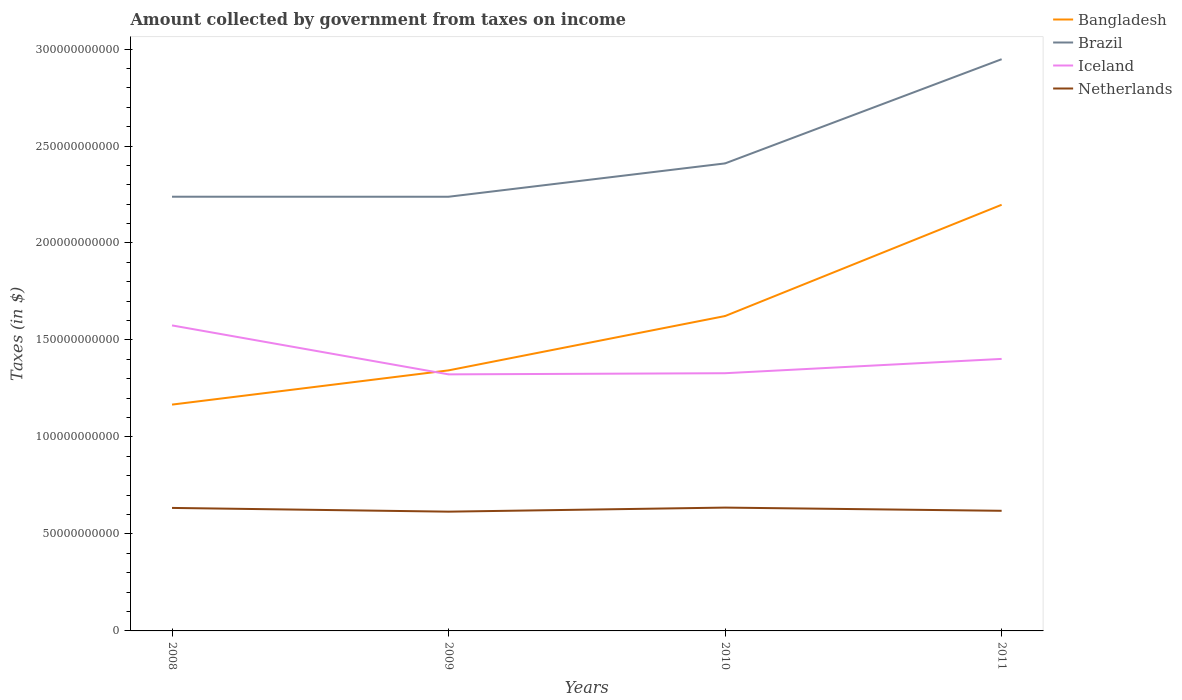Does the line corresponding to Netherlands intersect with the line corresponding to Bangladesh?
Offer a terse response. No. Is the number of lines equal to the number of legend labels?
Offer a very short reply. Yes. Across all years, what is the maximum amount collected by government from taxes on income in Netherlands?
Provide a short and direct response. 6.15e+1. What is the total amount collected by government from taxes on income in Brazil in the graph?
Your answer should be very brief. -7.09e+1. What is the difference between the highest and the second highest amount collected by government from taxes on income in Bangladesh?
Your answer should be compact. 1.03e+11. How many lines are there?
Ensure brevity in your answer.  4. Are the values on the major ticks of Y-axis written in scientific E-notation?
Provide a succinct answer. No. Does the graph contain any zero values?
Keep it short and to the point. No. Does the graph contain grids?
Make the answer very short. No. How many legend labels are there?
Ensure brevity in your answer.  4. What is the title of the graph?
Give a very brief answer. Amount collected by government from taxes on income. Does "Comoros" appear as one of the legend labels in the graph?
Provide a succinct answer. No. What is the label or title of the X-axis?
Keep it short and to the point. Years. What is the label or title of the Y-axis?
Give a very brief answer. Taxes (in $). What is the Taxes (in $) of Bangladesh in 2008?
Give a very brief answer. 1.17e+11. What is the Taxes (in $) of Brazil in 2008?
Ensure brevity in your answer.  2.24e+11. What is the Taxes (in $) in Iceland in 2008?
Provide a succinct answer. 1.58e+11. What is the Taxes (in $) of Netherlands in 2008?
Your answer should be very brief. 6.34e+1. What is the Taxes (in $) in Bangladesh in 2009?
Your response must be concise. 1.34e+11. What is the Taxes (in $) in Brazil in 2009?
Your answer should be compact. 2.24e+11. What is the Taxes (in $) of Iceland in 2009?
Offer a terse response. 1.32e+11. What is the Taxes (in $) in Netherlands in 2009?
Provide a succinct answer. 6.15e+1. What is the Taxes (in $) in Bangladesh in 2010?
Keep it short and to the point. 1.62e+11. What is the Taxes (in $) in Brazil in 2010?
Ensure brevity in your answer.  2.41e+11. What is the Taxes (in $) in Iceland in 2010?
Your answer should be very brief. 1.33e+11. What is the Taxes (in $) of Netherlands in 2010?
Offer a terse response. 6.36e+1. What is the Taxes (in $) of Bangladesh in 2011?
Provide a short and direct response. 2.20e+11. What is the Taxes (in $) in Brazil in 2011?
Your response must be concise. 2.95e+11. What is the Taxes (in $) of Iceland in 2011?
Provide a short and direct response. 1.40e+11. What is the Taxes (in $) of Netherlands in 2011?
Make the answer very short. 6.19e+1. Across all years, what is the maximum Taxes (in $) of Bangladesh?
Offer a terse response. 2.20e+11. Across all years, what is the maximum Taxes (in $) of Brazil?
Your response must be concise. 2.95e+11. Across all years, what is the maximum Taxes (in $) of Iceland?
Ensure brevity in your answer.  1.58e+11. Across all years, what is the maximum Taxes (in $) of Netherlands?
Keep it short and to the point. 6.36e+1. Across all years, what is the minimum Taxes (in $) of Bangladesh?
Keep it short and to the point. 1.17e+11. Across all years, what is the minimum Taxes (in $) in Brazil?
Give a very brief answer. 2.24e+11. Across all years, what is the minimum Taxes (in $) of Iceland?
Your answer should be very brief. 1.32e+11. Across all years, what is the minimum Taxes (in $) of Netherlands?
Your answer should be compact. 6.15e+1. What is the total Taxes (in $) in Bangladesh in the graph?
Offer a terse response. 6.33e+11. What is the total Taxes (in $) in Brazil in the graph?
Your response must be concise. 9.84e+11. What is the total Taxes (in $) of Iceland in the graph?
Give a very brief answer. 5.63e+11. What is the total Taxes (in $) in Netherlands in the graph?
Your answer should be compact. 2.50e+11. What is the difference between the Taxes (in $) in Bangladesh in 2008 and that in 2009?
Provide a short and direct response. -1.76e+1. What is the difference between the Taxes (in $) of Brazil in 2008 and that in 2009?
Provide a short and direct response. 1.68e+07. What is the difference between the Taxes (in $) in Iceland in 2008 and that in 2009?
Your answer should be very brief. 2.52e+1. What is the difference between the Taxes (in $) in Netherlands in 2008 and that in 2009?
Your response must be concise. 1.93e+09. What is the difference between the Taxes (in $) in Bangladesh in 2008 and that in 2010?
Provide a short and direct response. -4.57e+1. What is the difference between the Taxes (in $) of Brazil in 2008 and that in 2010?
Your answer should be very brief. -1.72e+1. What is the difference between the Taxes (in $) of Iceland in 2008 and that in 2010?
Ensure brevity in your answer.  2.46e+1. What is the difference between the Taxes (in $) in Netherlands in 2008 and that in 2010?
Make the answer very short. -1.63e+08. What is the difference between the Taxes (in $) of Bangladesh in 2008 and that in 2011?
Give a very brief answer. -1.03e+11. What is the difference between the Taxes (in $) in Brazil in 2008 and that in 2011?
Provide a succinct answer. -7.09e+1. What is the difference between the Taxes (in $) of Iceland in 2008 and that in 2011?
Provide a short and direct response. 1.73e+1. What is the difference between the Taxes (in $) in Netherlands in 2008 and that in 2011?
Your answer should be compact. 1.49e+09. What is the difference between the Taxes (in $) of Bangladesh in 2009 and that in 2010?
Your answer should be compact. -2.80e+1. What is the difference between the Taxes (in $) in Brazil in 2009 and that in 2010?
Offer a terse response. -1.72e+1. What is the difference between the Taxes (in $) of Iceland in 2009 and that in 2010?
Ensure brevity in your answer.  -5.93e+08. What is the difference between the Taxes (in $) of Netherlands in 2009 and that in 2010?
Your response must be concise. -2.09e+09. What is the difference between the Taxes (in $) of Bangladesh in 2009 and that in 2011?
Your answer should be compact. -8.54e+1. What is the difference between the Taxes (in $) in Brazil in 2009 and that in 2011?
Your answer should be very brief. -7.09e+1. What is the difference between the Taxes (in $) in Iceland in 2009 and that in 2011?
Provide a succinct answer. -7.97e+09. What is the difference between the Taxes (in $) in Netherlands in 2009 and that in 2011?
Provide a succinct answer. -4.40e+08. What is the difference between the Taxes (in $) in Bangladesh in 2010 and that in 2011?
Your answer should be very brief. -5.74e+1. What is the difference between the Taxes (in $) of Brazil in 2010 and that in 2011?
Your response must be concise. -5.37e+1. What is the difference between the Taxes (in $) of Iceland in 2010 and that in 2011?
Offer a terse response. -7.37e+09. What is the difference between the Taxes (in $) in Netherlands in 2010 and that in 2011?
Provide a succinct answer. 1.65e+09. What is the difference between the Taxes (in $) of Bangladesh in 2008 and the Taxes (in $) of Brazil in 2009?
Make the answer very short. -1.07e+11. What is the difference between the Taxes (in $) of Bangladesh in 2008 and the Taxes (in $) of Iceland in 2009?
Keep it short and to the point. -1.56e+1. What is the difference between the Taxes (in $) of Bangladesh in 2008 and the Taxes (in $) of Netherlands in 2009?
Give a very brief answer. 5.52e+1. What is the difference between the Taxes (in $) in Brazil in 2008 and the Taxes (in $) in Iceland in 2009?
Keep it short and to the point. 9.16e+1. What is the difference between the Taxes (in $) in Brazil in 2008 and the Taxes (in $) in Netherlands in 2009?
Your response must be concise. 1.62e+11. What is the difference between the Taxes (in $) in Iceland in 2008 and the Taxes (in $) in Netherlands in 2009?
Offer a very short reply. 9.60e+1. What is the difference between the Taxes (in $) in Bangladesh in 2008 and the Taxes (in $) in Brazil in 2010?
Give a very brief answer. -1.24e+11. What is the difference between the Taxes (in $) in Bangladesh in 2008 and the Taxes (in $) in Iceland in 2010?
Provide a succinct answer. -1.62e+1. What is the difference between the Taxes (in $) in Bangladesh in 2008 and the Taxes (in $) in Netherlands in 2010?
Provide a short and direct response. 5.31e+1. What is the difference between the Taxes (in $) in Brazil in 2008 and the Taxes (in $) in Iceland in 2010?
Keep it short and to the point. 9.10e+1. What is the difference between the Taxes (in $) of Brazil in 2008 and the Taxes (in $) of Netherlands in 2010?
Provide a succinct answer. 1.60e+11. What is the difference between the Taxes (in $) in Iceland in 2008 and the Taxes (in $) in Netherlands in 2010?
Make the answer very short. 9.39e+1. What is the difference between the Taxes (in $) of Bangladesh in 2008 and the Taxes (in $) of Brazil in 2011?
Keep it short and to the point. -1.78e+11. What is the difference between the Taxes (in $) in Bangladesh in 2008 and the Taxes (in $) in Iceland in 2011?
Offer a very short reply. -2.36e+1. What is the difference between the Taxes (in $) in Bangladesh in 2008 and the Taxes (in $) in Netherlands in 2011?
Your response must be concise. 5.48e+1. What is the difference between the Taxes (in $) in Brazil in 2008 and the Taxes (in $) in Iceland in 2011?
Ensure brevity in your answer.  8.36e+1. What is the difference between the Taxes (in $) in Brazil in 2008 and the Taxes (in $) in Netherlands in 2011?
Keep it short and to the point. 1.62e+11. What is the difference between the Taxes (in $) of Iceland in 2008 and the Taxes (in $) of Netherlands in 2011?
Provide a short and direct response. 9.56e+1. What is the difference between the Taxes (in $) in Bangladesh in 2009 and the Taxes (in $) in Brazil in 2010?
Provide a short and direct response. -1.07e+11. What is the difference between the Taxes (in $) of Bangladesh in 2009 and the Taxes (in $) of Iceland in 2010?
Offer a terse response. 1.47e+09. What is the difference between the Taxes (in $) of Bangladesh in 2009 and the Taxes (in $) of Netherlands in 2010?
Provide a short and direct response. 7.08e+1. What is the difference between the Taxes (in $) of Brazil in 2009 and the Taxes (in $) of Iceland in 2010?
Give a very brief answer. 9.10e+1. What is the difference between the Taxes (in $) of Brazil in 2009 and the Taxes (in $) of Netherlands in 2010?
Your response must be concise. 1.60e+11. What is the difference between the Taxes (in $) in Iceland in 2009 and the Taxes (in $) in Netherlands in 2010?
Provide a short and direct response. 6.87e+1. What is the difference between the Taxes (in $) of Bangladesh in 2009 and the Taxes (in $) of Brazil in 2011?
Your answer should be compact. -1.60e+11. What is the difference between the Taxes (in $) of Bangladesh in 2009 and the Taxes (in $) of Iceland in 2011?
Ensure brevity in your answer.  -5.91e+09. What is the difference between the Taxes (in $) of Bangladesh in 2009 and the Taxes (in $) of Netherlands in 2011?
Offer a very short reply. 7.24e+1. What is the difference between the Taxes (in $) of Brazil in 2009 and the Taxes (in $) of Iceland in 2011?
Give a very brief answer. 8.36e+1. What is the difference between the Taxes (in $) of Brazil in 2009 and the Taxes (in $) of Netherlands in 2011?
Your answer should be compact. 1.62e+11. What is the difference between the Taxes (in $) in Iceland in 2009 and the Taxes (in $) in Netherlands in 2011?
Provide a short and direct response. 7.03e+1. What is the difference between the Taxes (in $) of Bangladesh in 2010 and the Taxes (in $) of Brazil in 2011?
Give a very brief answer. -1.32e+11. What is the difference between the Taxes (in $) in Bangladesh in 2010 and the Taxes (in $) in Iceland in 2011?
Ensure brevity in your answer.  2.21e+1. What is the difference between the Taxes (in $) of Bangladesh in 2010 and the Taxes (in $) of Netherlands in 2011?
Your answer should be compact. 1.00e+11. What is the difference between the Taxes (in $) of Brazil in 2010 and the Taxes (in $) of Iceland in 2011?
Keep it short and to the point. 1.01e+11. What is the difference between the Taxes (in $) in Brazil in 2010 and the Taxes (in $) in Netherlands in 2011?
Provide a succinct answer. 1.79e+11. What is the difference between the Taxes (in $) in Iceland in 2010 and the Taxes (in $) in Netherlands in 2011?
Your answer should be compact. 7.09e+1. What is the average Taxes (in $) of Bangladesh per year?
Offer a terse response. 1.58e+11. What is the average Taxes (in $) in Brazil per year?
Offer a terse response. 2.46e+11. What is the average Taxes (in $) in Iceland per year?
Offer a terse response. 1.41e+11. What is the average Taxes (in $) in Netherlands per year?
Offer a terse response. 6.26e+1. In the year 2008, what is the difference between the Taxes (in $) in Bangladesh and Taxes (in $) in Brazil?
Provide a succinct answer. -1.07e+11. In the year 2008, what is the difference between the Taxes (in $) in Bangladesh and Taxes (in $) in Iceland?
Give a very brief answer. -4.08e+1. In the year 2008, what is the difference between the Taxes (in $) of Bangladesh and Taxes (in $) of Netherlands?
Your response must be concise. 5.33e+1. In the year 2008, what is the difference between the Taxes (in $) in Brazil and Taxes (in $) in Iceland?
Make the answer very short. 6.63e+1. In the year 2008, what is the difference between the Taxes (in $) of Brazil and Taxes (in $) of Netherlands?
Provide a short and direct response. 1.60e+11. In the year 2008, what is the difference between the Taxes (in $) in Iceland and Taxes (in $) in Netherlands?
Offer a very short reply. 9.41e+1. In the year 2009, what is the difference between the Taxes (in $) of Bangladesh and Taxes (in $) of Brazil?
Provide a succinct answer. -8.95e+1. In the year 2009, what is the difference between the Taxes (in $) in Bangladesh and Taxes (in $) in Iceland?
Give a very brief answer. 2.06e+09. In the year 2009, what is the difference between the Taxes (in $) of Bangladesh and Taxes (in $) of Netherlands?
Make the answer very short. 7.28e+1. In the year 2009, what is the difference between the Taxes (in $) of Brazil and Taxes (in $) of Iceland?
Offer a terse response. 9.16e+1. In the year 2009, what is the difference between the Taxes (in $) in Brazil and Taxes (in $) in Netherlands?
Your answer should be very brief. 1.62e+11. In the year 2009, what is the difference between the Taxes (in $) in Iceland and Taxes (in $) in Netherlands?
Provide a short and direct response. 7.08e+1. In the year 2010, what is the difference between the Taxes (in $) of Bangladesh and Taxes (in $) of Brazil?
Offer a very short reply. -7.87e+1. In the year 2010, what is the difference between the Taxes (in $) of Bangladesh and Taxes (in $) of Iceland?
Offer a terse response. 2.95e+1. In the year 2010, what is the difference between the Taxes (in $) in Bangladesh and Taxes (in $) in Netherlands?
Provide a succinct answer. 9.88e+1. In the year 2010, what is the difference between the Taxes (in $) of Brazil and Taxes (in $) of Iceland?
Offer a terse response. 1.08e+11. In the year 2010, what is the difference between the Taxes (in $) of Brazil and Taxes (in $) of Netherlands?
Give a very brief answer. 1.77e+11. In the year 2010, what is the difference between the Taxes (in $) of Iceland and Taxes (in $) of Netherlands?
Your response must be concise. 6.93e+1. In the year 2011, what is the difference between the Taxes (in $) in Bangladesh and Taxes (in $) in Brazil?
Your response must be concise. -7.50e+1. In the year 2011, what is the difference between the Taxes (in $) in Bangladesh and Taxes (in $) in Iceland?
Your response must be concise. 7.95e+1. In the year 2011, what is the difference between the Taxes (in $) of Bangladesh and Taxes (in $) of Netherlands?
Provide a succinct answer. 1.58e+11. In the year 2011, what is the difference between the Taxes (in $) of Brazil and Taxes (in $) of Iceland?
Provide a short and direct response. 1.55e+11. In the year 2011, what is the difference between the Taxes (in $) of Brazil and Taxes (in $) of Netherlands?
Offer a terse response. 2.33e+11. In the year 2011, what is the difference between the Taxes (in $) of Iceland and Taxes (in $) of Netherlands?
Ensure brevity in your answer.  7.83e+1. What is the ratio of the Taxes (in $) of Bangladesh in 2008 to that in 2009?
Provide a succinct answer. 0.87. What is the ratio of the Taxes (in $) in Iceland in 2008 to that in 2009?
Give a very brief answer. 1.19. What is the ratio of the Taxes (in $) in Netherlands in 2008 to that in 2009?
Make the answer very short. 1.03. What is the ratio of the Taxes (in $) in Bangladesh in 2008 to that in 2010?
Provide a short and direct response. 0.72. What is the ratio of the Taxes (in $) of Brazil in 2008 to that in 2010?
Your answer should be compact. 0.93. What is the ratio of the Taxes (in $) in Iceland in 2008 to that in 2010?
Provide a succinct answer. 1.19. What is the ratio of the Taxes (in $) in Bangladesh in 2008 to that in 2011?
Make the answer very short. 0.53. What is the ratio of the Taxes (in $) in Brazil in 2008 to that in 2011?
Keep it short and to the point. 0.76. What is the ratio of the Taxes (in $) of Iceland in 2008 to that in 2011?
Give a very brief answer. 1.12. What is the ratio of the Taxes (in $) of Bangladesh in 2009 to that in 2010?
Keep it short and to the point. 0.83. What is the ratio of the Taxes (in $) of Brazil in 2009 to that in 2010?
Your answer should be compact. 0.93. What is the ratio of the Taxes (in $) of Netherlands in 2009 to that in 2010?
Your answer should be compact. 0.97. What is the ratio of the Taxes (in $) of Bangladesh in 2009 to that in 2011?
Your response must be concise. 0.61. What is the ratio of the Taxes (in $) in Brazil in 2009 to that in 2011?
Give a very brief answer. 0.76. What is the ratio of the Taxes (in $) in Iceland in 2009 to that in 2011?
Keep it short and to the point. 0.94. What is the ratio of the Taxes (in $) of Bangladesh in 2010 to that in 2011?
Offer a terse response. 0.74. What is the ratio of the Taxes (in $) of Brazil in 2010 to that in 2011?
Provide a succinct answer. 0.82. What is the ratio of the Taxes (in $) of Iceland in 2010 to that in 2011?
Give a very brief answer. 0.95. What is the ratio of the Taxes (in $) of Netherlands in 2010 to that in 2011?
Your answer should be compact. 1.03. What is the difference between the highest and the second highest Taxes (in $) of Bangladesh?
Keep it short and to the point. 5.74e+1. What is the difference between the highest and the second highest Taxes (in $) in Brazil?
Your answer should be very brief. 5.37e+1. What is the difference between the highest and the second highest Taxes (in $) in Iceland?
Provide a short and direct response. 1.73e+1. What is the difference between the highest and the second highest Taxes (in $) of Netherlands?
Make the answer very short. 1.63e+08. What is the difference between the highest and the lowest Taxes (in $) in Bangladesh?
Make the answer very short. 1.03e+11. What is the difference between the highest and the lowest Taxes (in $) of Brazil?
Your answer should be compact. 7.09e+1. What is the difference between the highest and the lowest Taxes (in $) of Iceland?
Provide a succinct answer. 2.52e+1. What is the difference between the highest and the lowest Taxes (in $) in Netherlands?
Make the answer very short. 2.09e+09. 